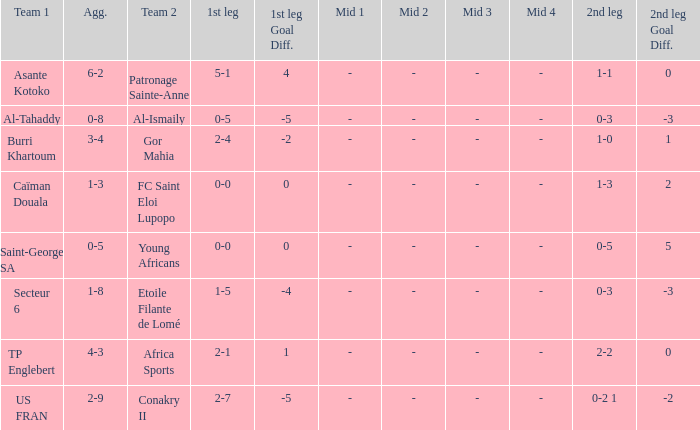What was the 2nd leg score between Patronage Sainte-Anne and Asante Kotoko? 1-1. 